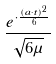<formula> <loc_0><loc_0><loc_500><loc_500>\frac { e ^ { \cdot \frac { ( a \cdot t ) ^ { 2 } } { 6 } } } { \sqrt { 6 \mu } }</formula> 